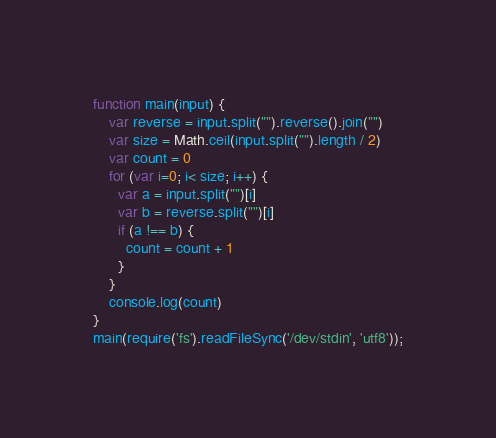<code> <loc_0><loc_0><loc_500><loc_500><_JavaScript_>function main(input) {
    var reverse = input.split("").reverse().join("")
    var size = Math.ceil(input.split("").length / 2) 
    var count = 0
    for (var i=0; i< size; i++) {
      var a = input.split("")[i]
      var b = reverse.split("")[i]
      if (a !== b) {
        count = count + 1
      }
    }
    console.log(count)
}
main(require('fs').readFileSync('/dev/stdin', 'utf8'));
</code> 